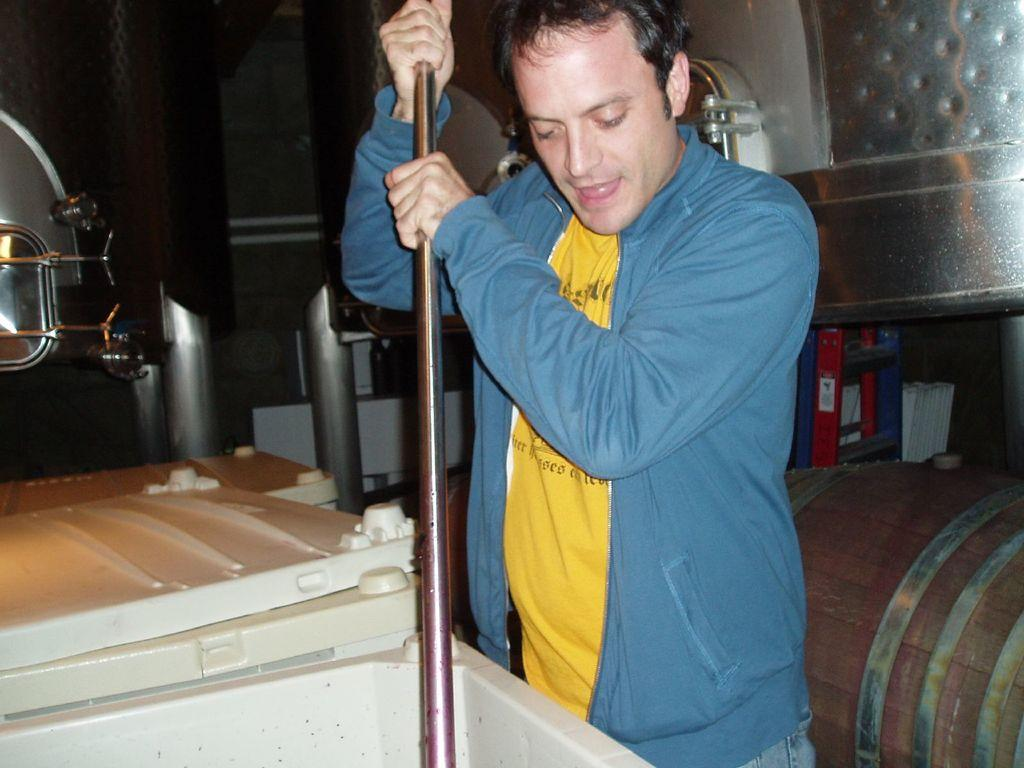What is the main subject in the front of the image? There is a man standing in the front of the image. What is the man holding in his hand? The man is holding a stick in his hand. Can you describe the objects in the background of the image? In the background, there are objects with red, white, and silver colors. What type of thread is being used to create the details on the objects in the image? There is no mention of thread or details being created on the objects in the image. The objects are described by their colors, but not by any specific details or materials used. 